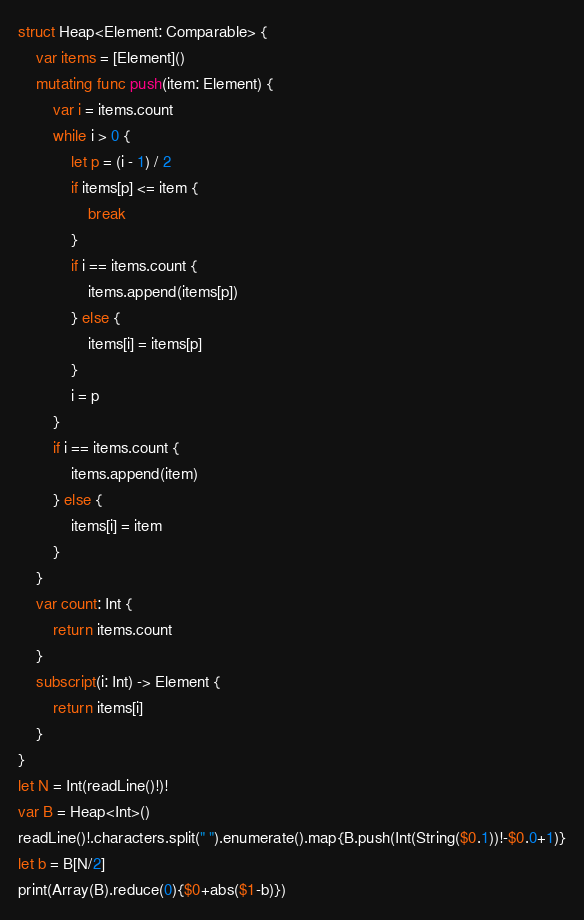Convert code to text. <code><loc_0><loc_0><loc_500><loc_500><_Swift_>struct Heap<Element: Comparable> {
    var items = [Element]()
    mutating func push(item: Element) {
        var i = items.count
        while i > 0 {
            let p = (i - 1) / 2
            if items[p] <= item {
                break
            }
            if i == items.count {
                items.append(items[p])
            } else {
                items[i] = items[p]
            }
            i = p
        }
        if i == items.count {
            items.append(item)
        } else {
            items[i] = item
        }
    }
    var count: Int {
        return items.count
    }
    subscript(i: Int) -> Element {
        return items[i]
    }
}
let N = Int(readLine()!)!
var B = Heap<Int>()
readLine()!.characters.split(" ").enumerate().map{B.push(Int(String($0.1))!-$0.0+1)}
let b = B[N/2]
print(Array(B).reduce(0){$0+abs($1-b)})</code> 